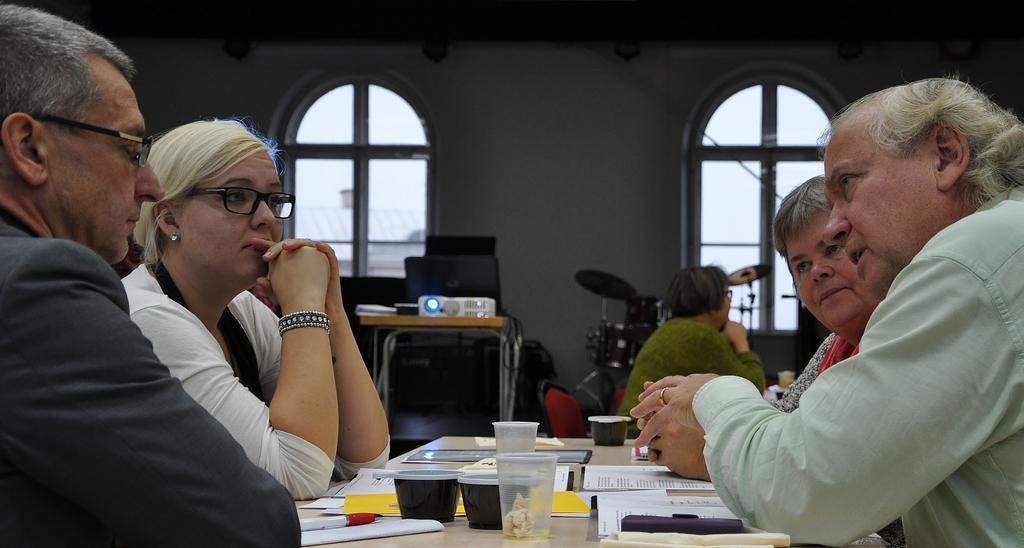Describe this image in one or two sentences. In this image we can see few people sitting near the table. There are many objects placed on the table at the bottom of the image. We can see a projector on the table. There are few musical instruments in the image. A lady is sitting on the chair. 